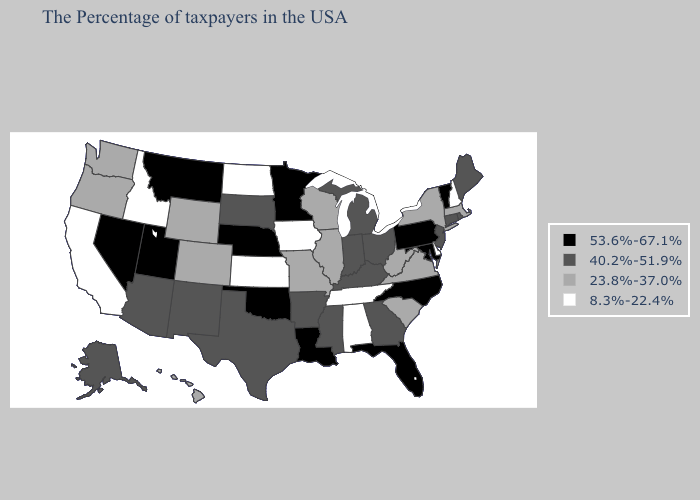Among the states that border Virginia , which have the lowest value?
Write a very short answer. Tennessee. Does Iowa have the lowest value in the USA?
Write a very short answer. Yes. What is the value of Texas?
Write a very short answer. 40.2%-51.9%. Does New Hampshire have the lowest value in the USA?
Concise answer only. Yes. Is the legend a continuous bar?
Write a very short answer. No. What is the highest value in the South ?
Give a very brief answer. 53.6%-67.1%. What is the value of Nevada?
Quick response, please. 53.6%-67.1%. Does Minnesota have the highest value in the USA?
Keep it brief. Yes. What is the value of North Carolina?
Keep it brief. 53.6%-67.1%. Does South Carolina have the highest value in the USA?
Give a very brief answer. No. Does Wisconsin have the lowest value in the USA?
Concise answer only. No. Name the states that have a value in the range 40.2%-51.9%?
Give a very brief answer. Maine, Rhode Island, Connecticut, New Jersey, Ohio, Georgia, Michigan, Kentucky, Indiana, Mississippi, Arkansas, Texas, South Dakota, New Mexico, Arizona, Alaska. What is the value of Maine?
Be succinct. 40.2%-51.9%. Which states have the lowest value in the MidWest?
Quick response, please. Iowa, Kansas, North Dakota. Does Delaware have the lowest value in the USA?
Give a very brief answer. Yes. 